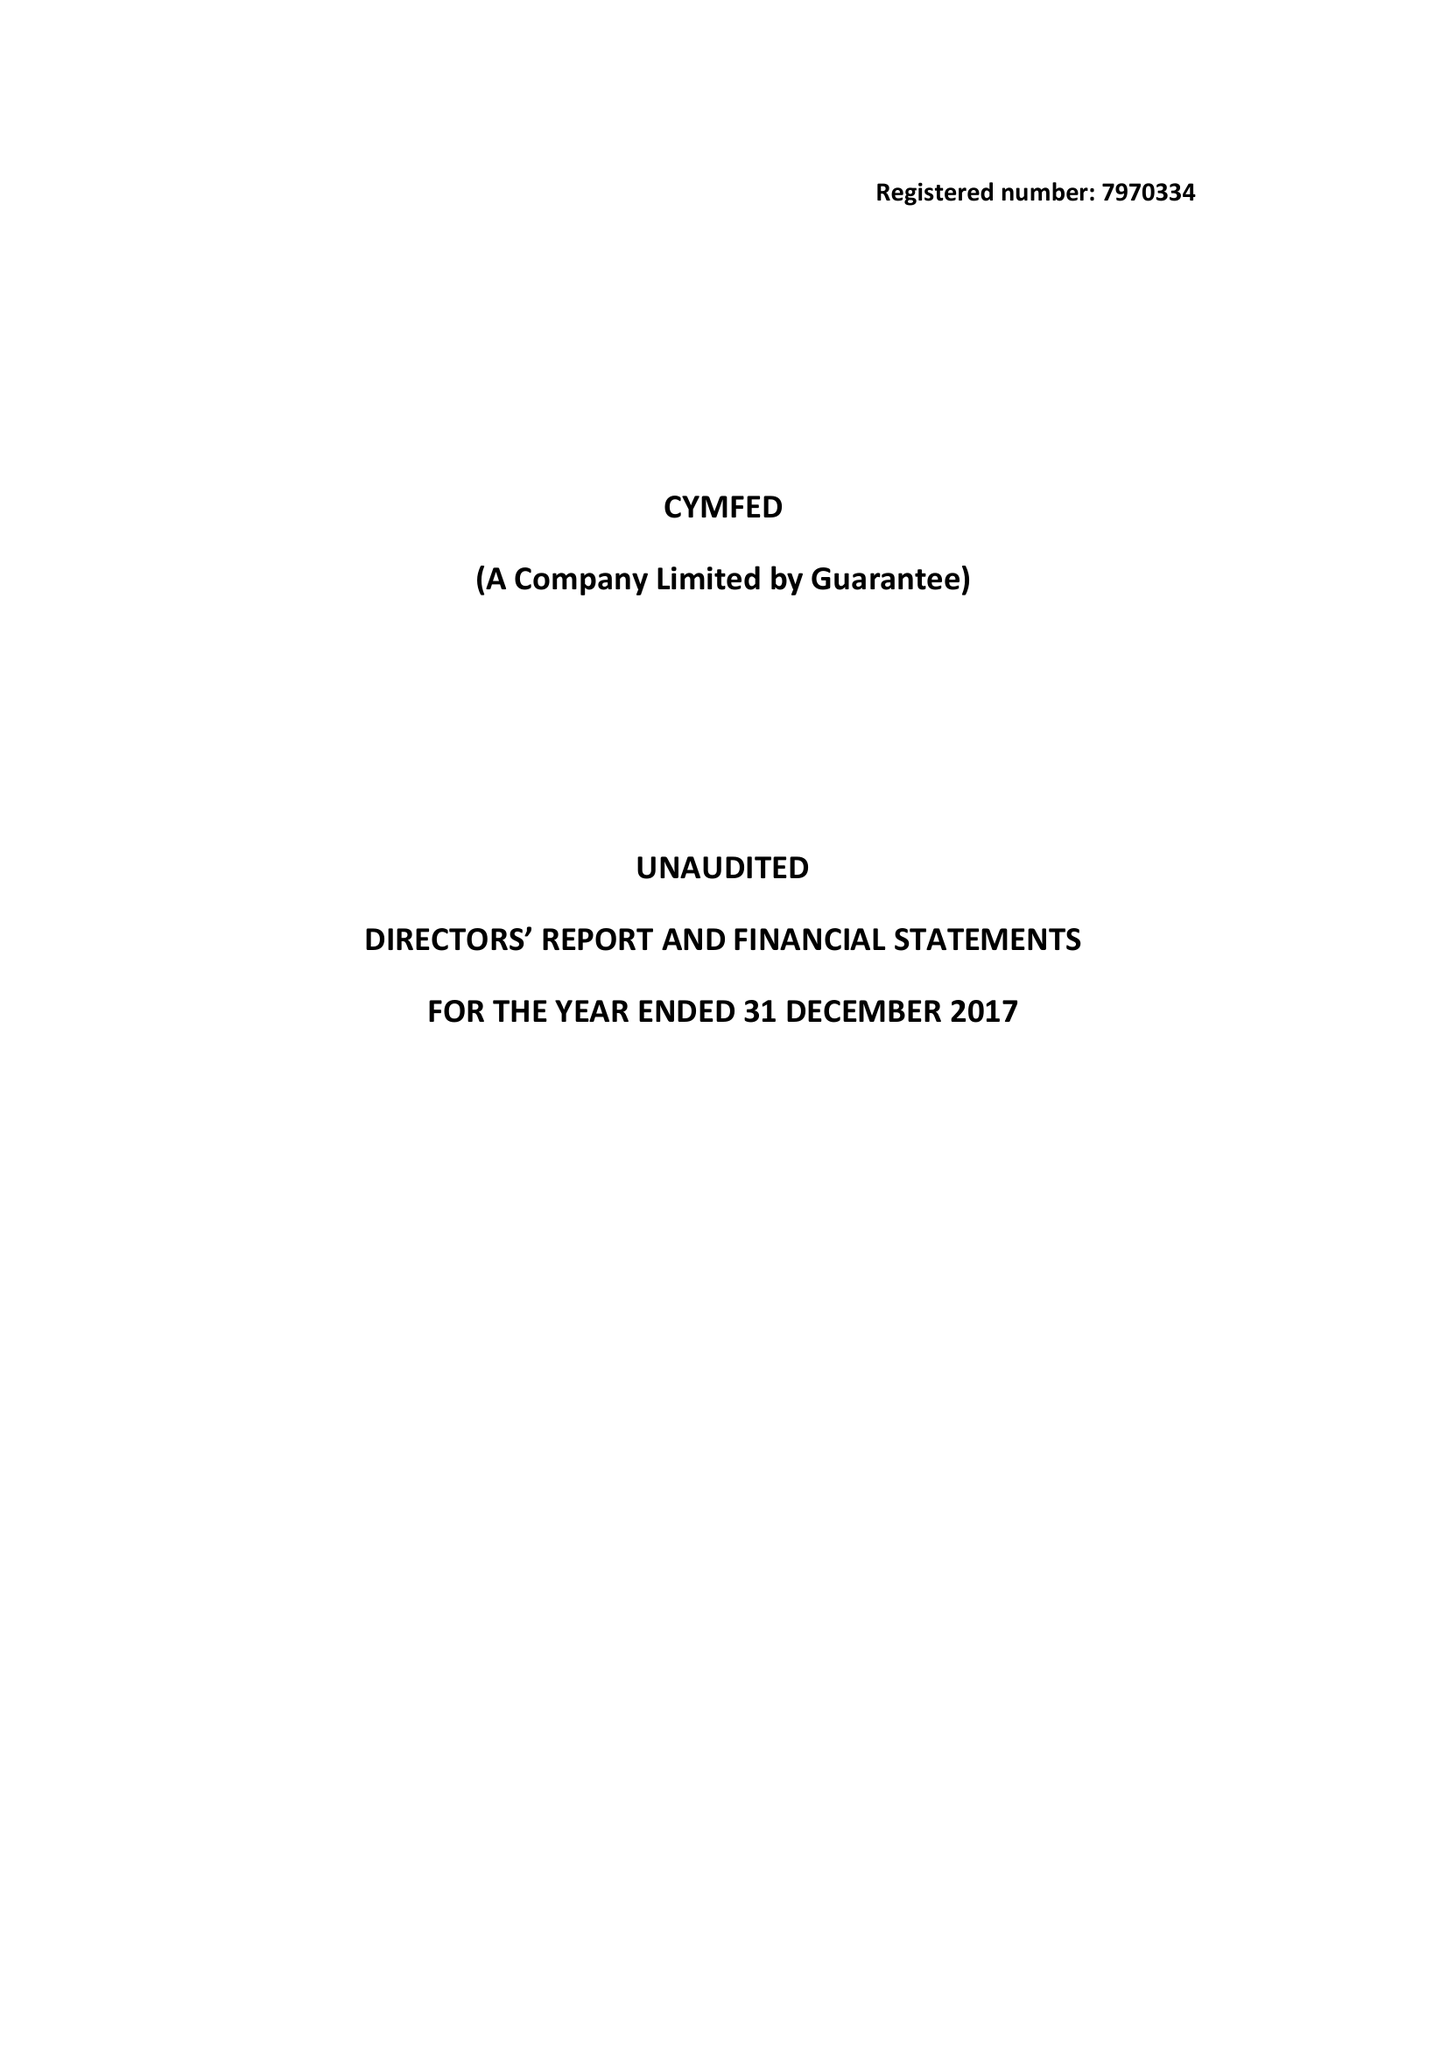What is the value for the report_date?
Answer the question using a single word or phrase. 2017-12-31 